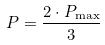<formula> <loc_0><loc_0><loc_500><loc_500>P = \frac { 2 \cdot P _ { \max } } { 3 }</formula> 